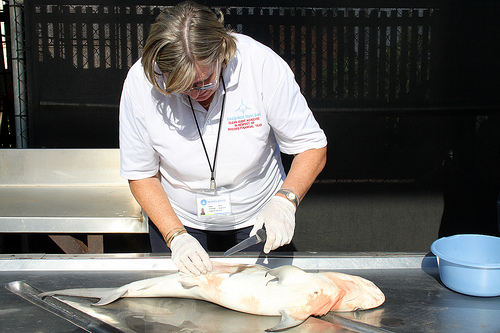<image>
Can you confirm if the gloves is in front of the watch? No. The gloves is not in front of the watch. The spatial positioning shows a different relationship between these objects. 